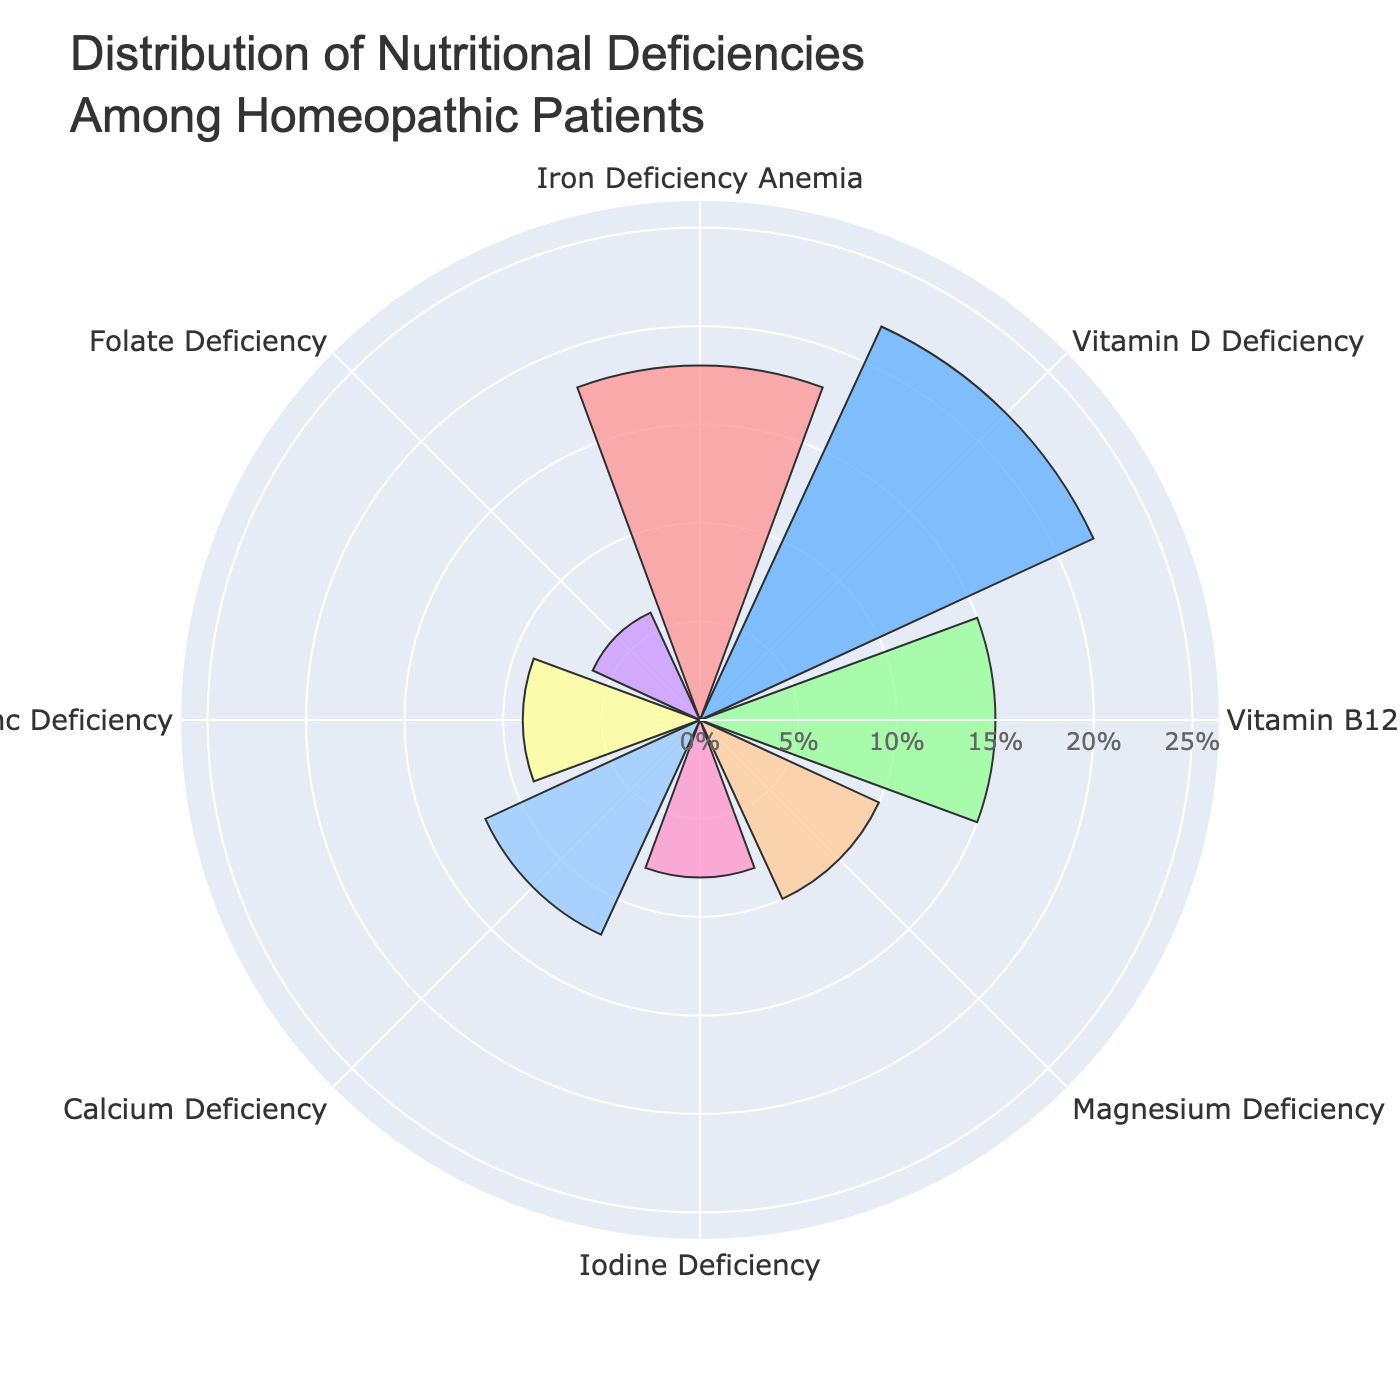What's the title of the chart? The title is located at the top of the chart. To find it, look for the largest text, typically centered.
Answer: Distribution of Nutritional Deficiencies Among Homeopathic Patients How many types of nutritional deficiencies are represented in the chart? Count the unique labels along the angular axis of the polar area chart. Each label represents one type of nutritional deficiency.
Answer: 8 Which nutritional deficiency has the highest percentage of patients? Identify the segment with the largest radial length, as this corresponds to the highest percentage.
Answer: Vitamin D Deficiency What is the difference in the percentage of patients between Iron Deficiency Anemia and Iodine Deficiency? Subtract the percentage value of Iodine Deficiency from that of Iron Deficiency Anemia. Iron Deficiency Anemia is 18%, and Iodine Deficiency is 8%.
Answer: 10% What is the combined percentage of patients with Vitamin D Deficiency and Calcium Deficiency? Add the percentage values of Vitamin D Deficiency and Calcium Deficiency. Vitamin D Deficiency is 22%, and Calcium Deficiency is 12%.
Answer: 34% Which deficiency is more common, Zinc Deficiency or Magnesium Deficiency? Compare the radial lengths of the segments for Zinc Deficiency and Magnesium Deficiency. Zinc Deficiency is 9%, and Magnesium Deficiency is 10%.
Answer: Magnesium Deficiency What is the average percentage of patients with the three least common deficiencies? Identify the three deficiencies with the smallest radial lengths, then average their percentage values. The three least common deficiencies are Folate Deficiency (6%), Iodine Deficiency (8%), and Zinc Deficiency (9%). The average is (6 + 8 + 9)/3.
Answer: 7.67% Which deficiency has the third highest percentage of patients? Order the deficiencies by the length of their radial segments and pick the third longest one.
Answer: Iron Deficiency Anemia Do more patients have Vitamin B12 Deficiency or Calcium Deficiency? Compare the radial lengths of the segments for Vitamin B12 Deficiency (15%) and Calcium Deficiency (12%).
Answer: Vitamin B12 Deficiency 